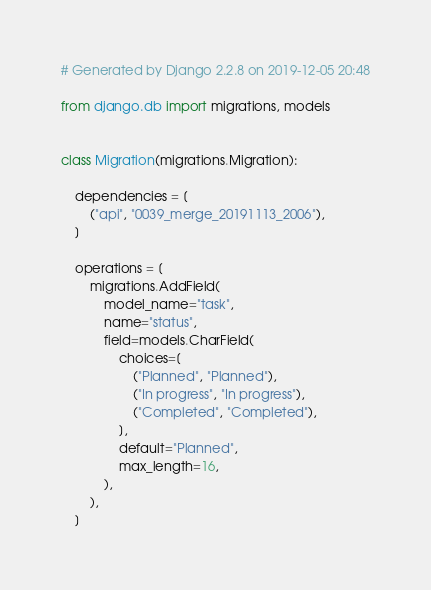Convert code to text. <code><loc_0><loc_0><loc_500><loc_500><_Python_># Generated by Django 2.2.8 on 2019-12-05 20:48

from django.db import migrations, models


class Migration(migrations.Migration):

    dependencies = [
        ("api", "0039_merge_20191113_2006"),
    ]

    operations = [
        migrations.AddField(
            model_name="task",
            name="status",
            field=models.CharField(
                choices=[
                    ("Planned", "Planned"),
                    ("In progress", "In progress"),
                    ("Completed", "Completed"),
                ],
                default="Planned",
                max_length=16,
            ),
        ),
    ]
</code> 